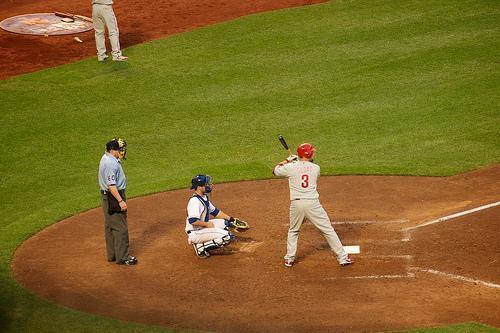How many batters are in the picture?
Give a very brief answer. 1. 